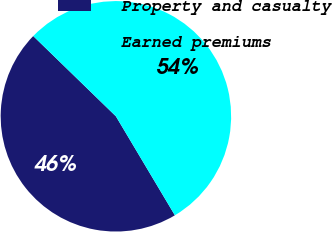Convert chart to OTSL. <chart><loc_0><loc_0><loc_500><loc_500><pie_chart><fcel>Property and casualty<fcel>Earned premiums<nl><fcel>45.82%<fcel>54.18%<nl></chart> 